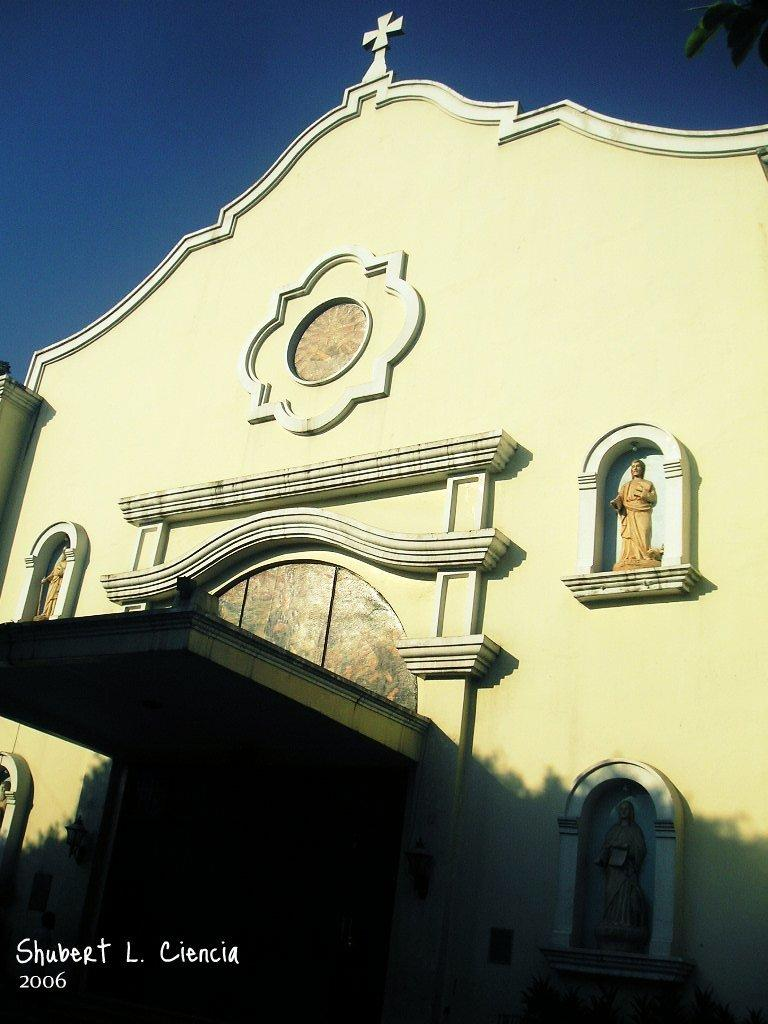What type of building is in the image? There is a church in the image. What decorative elements can be seen on the church? The church has sculptures on the wall. What is visible at the top of the image? The sky is visible at the top of the image. How many eggs are present in the church's basin in the image? There is no basin or eggs present in the image; it features a church with sculptures on the wall and sky visible at the top. 